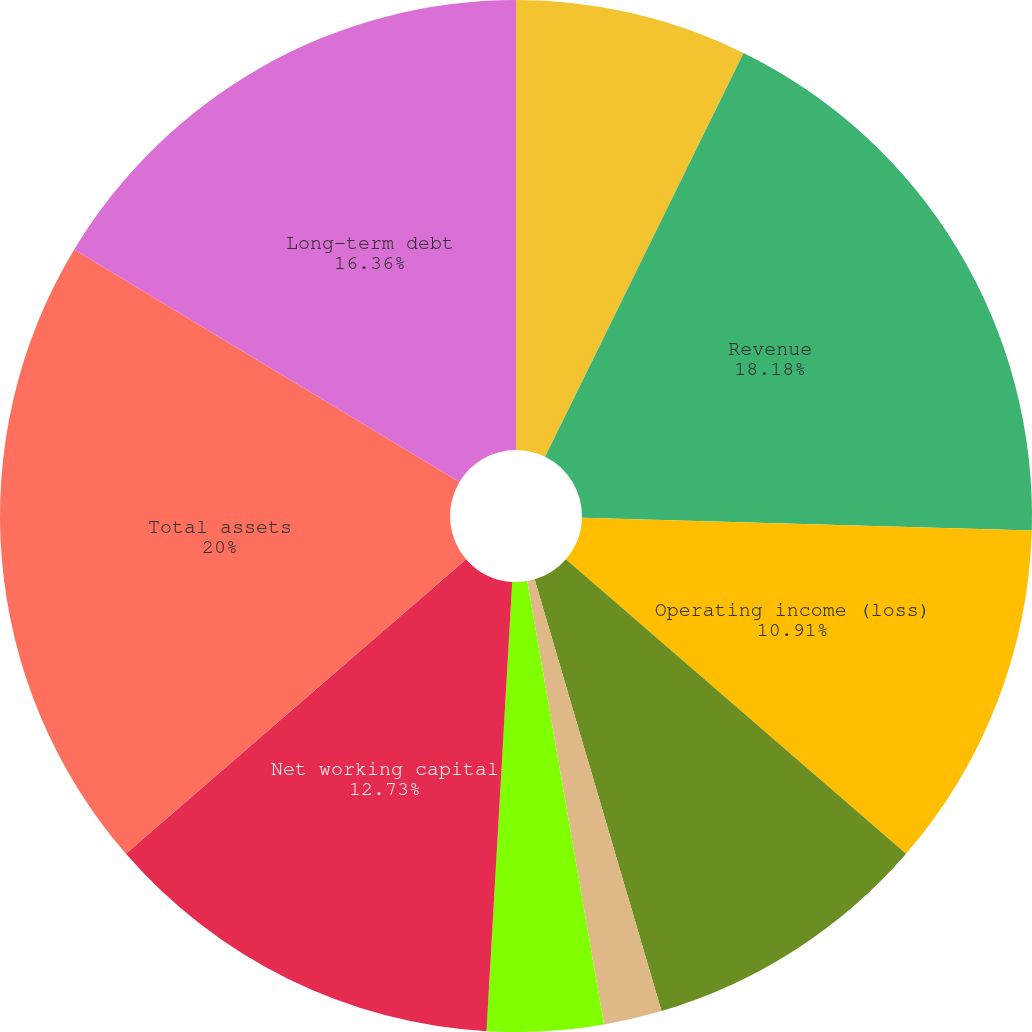Convert chart to OTSL. <chart><loc_0><loc_0><loc_500><loc_500><pie_chart><fcel>Millions of dollars except per<fcel>Revenue<fcel>Operating income (loss)<fcel>Income (loss) from continuing<fcel>Basic income (loss) per share<fcel>Diluted income (loss) per<fcel>Cash dividends per share<fcel>Net working capital<fcel>Total assets<fcel>Long-term debt<nl><fcel>7.27%<fcel>18.18%<fcel>10.91%<fcel>9.09%<fcel>1.82%<fcel>3.64%<fcel>0.0%<fcel>12.73%<fcel>20.0%<fcel>16.36%<nl></chart> 